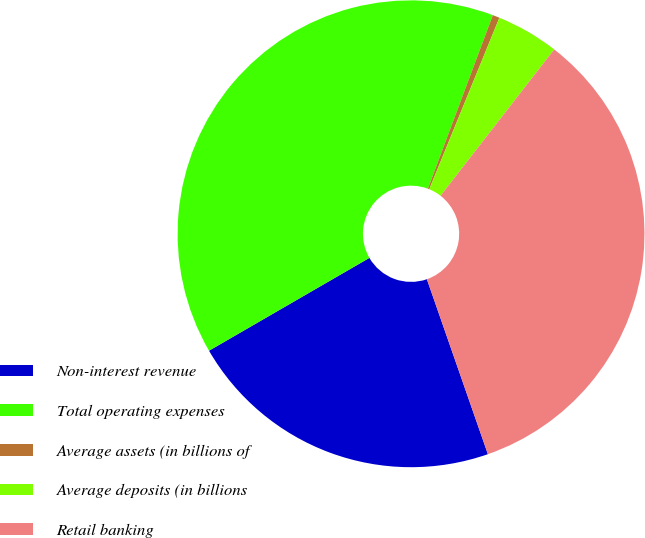<chart> <loc_0><loc_0><loc_500><loc_500><pie_chart><fcel>Non-interest revenue<fcel>Total operating expenses<fcel>Average assets (in billions of<fcel>Average deposits (in billions<fcel>Retail banking<nl><fcel>21.99%<fcel>39.05%<fcel>0.48%<fcel>4.33%<fcel>34.15%<nl></chart> 